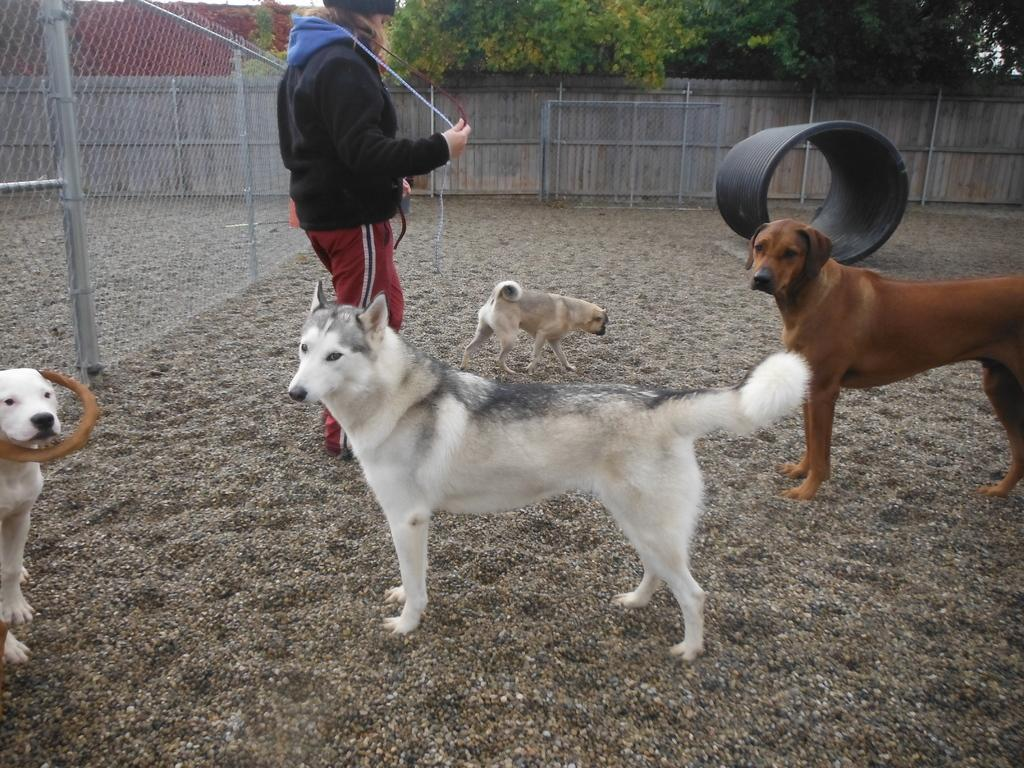What is the main subject of the image? There is a person standing in the image. What animals are present in the image? There are dogs on the surface in the image. What type of barrier can be seen in the image? There is a fence in the image. What can be seen in the background of the image? There is a wooden wall, trees, and a roof top visible in the background of the image. What type of wren is perched on the person's shoulder in the image? There is no wren present in the image; only a person and dogs are visible. What type of smile does the person have in the image? The provided facts do not mention the person's facial expression, so it cannot be determined from the image. 